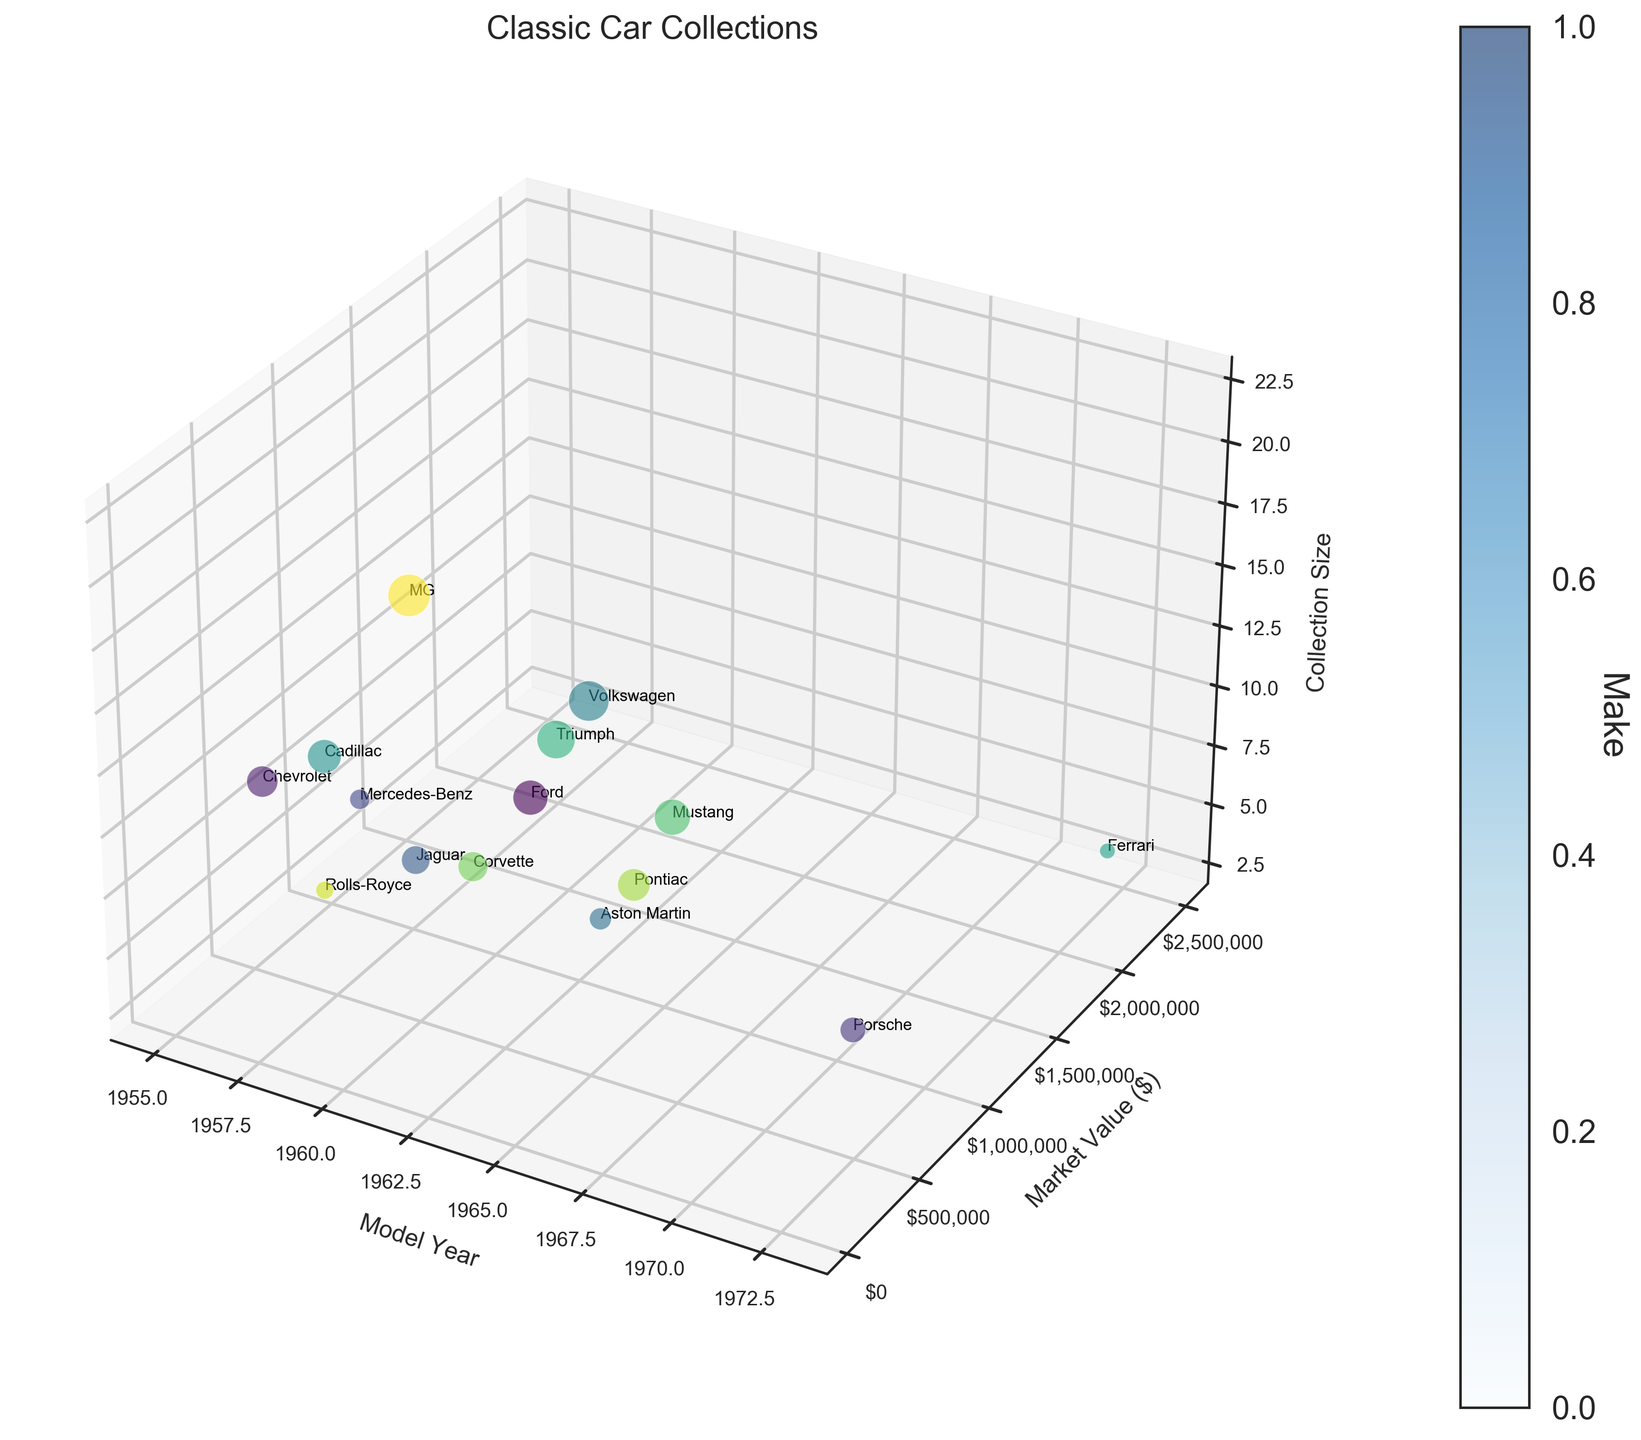what is the title of the figure? The title of the figure is displayed at the top in a larger and bold font. Reading the text tells us the title.
Answer: Classic Car Collections Which make has the highest market value? Look at the highest point on the 'Market Value' axis and find the make associated with it. The highest market value on the chart is $2,500,000, which corresponds to Ferrari.
Answer: Ferrari Which model year witnessed the largest collection size? Identify the bubble with the largest size by comparing the sizes of all bubbles. The largest bubble is labeled MG, with a collection size of 22. Looking at the 'Model Year' axis, this bubble corresponds to 1962.
Answer: 1962 How many makes are there in total? Count the number of different makes labeled on the bubbles. Each bubble has a distinct make associated with it. There are 15 labeled bubbles.
Answer: 15 What is the average market value of the collections? Sum up all the market values and then divide by the number of makes. The total market value sum is $6,415,000, and there are 15 makes. So, the average market value is $6,415,000/15.
Answer: $427,666.67 Which make has the smallest collection size, and what is its market value? Look for the smallest bubble and check its label and corresponding market value. The smallest bubble corresponds to Ferrari with a collection size of 3 and a market value of $2,500,000.
Answer: Ferrari, $2,500,000 What is the total collection size of makes from the 1960s? Identify the bubbles corresponding to model years from 1960 to 1969, then sum up their collection sizes. The makes from the 1960s include Jaguar, Aston Martin, Volkswagen, Triumph, Mustang, Corvette, and Pontiac. Adding their collection sizes gives 10 + 6 + 20 + 18 + 16 + 11 + 13 = 94.
Answer: 94 Which make from the 1950s has the highest market value? Identify the bubbles corresponding to model years from 1950 to 1959 and compare their market values. The makes are Mercedes-Benz, Cadillac, and Rolls-Royce. Mercedes-Benz has the highest market value of $1,200,000.
Answer: Mercedes-Benz Compare the market value of Chevrolet and Ford. Which one is higher? Find the bubbles labeled Chevrolet and Ford and compare their market values by checking the 'Market Value' axis positions. Chevrolet has a market value of $180,000, while Ford's market value is $125,000. Thus, Chevrolet's market value is higher.
Answer: Chevrolet 